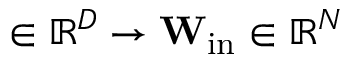<formula> <loc_0><loc_0><loc_500><loc_500>\ u \in \mathbb { R } ^ { D } \to W _ { i n } \ u \in \mathbb { R } ^ { N }</formula> 